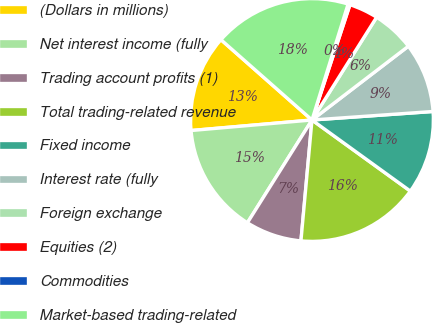Convert chart to OTSL. <chart><loc_0><loc_0><loc_500><loc_500><pie_chart><fcel>(Dollars in millions)<fcel>Net interest income (fully<fcel>Trading account profits (1)<fcel>Total trading-related revenue<fcel>Fixed income<fcel>Interest rate (fully<fcel>Foreign exchange<fcel>Equities (2)<fcel>Commodities<fcel>Market-based trading-related<nl><fcel>12.89%<fcel>14.69%<fcel>7.48%<fcel>16.49%<fcel>11.08%<fcel>9.28%<fcel>5.67%<fcel>3.87%<fcel>0.26%<fcel>18.3%<nl></chart> 